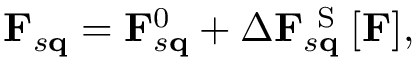Convert formula to latex. <formula><loc_0><loc_0><loc_500><loc_500>F _ { s q } = F _ { s q } ^ { 0 } + \Delta F _ { s q } ^ { S } [ F ] ,</formula> 